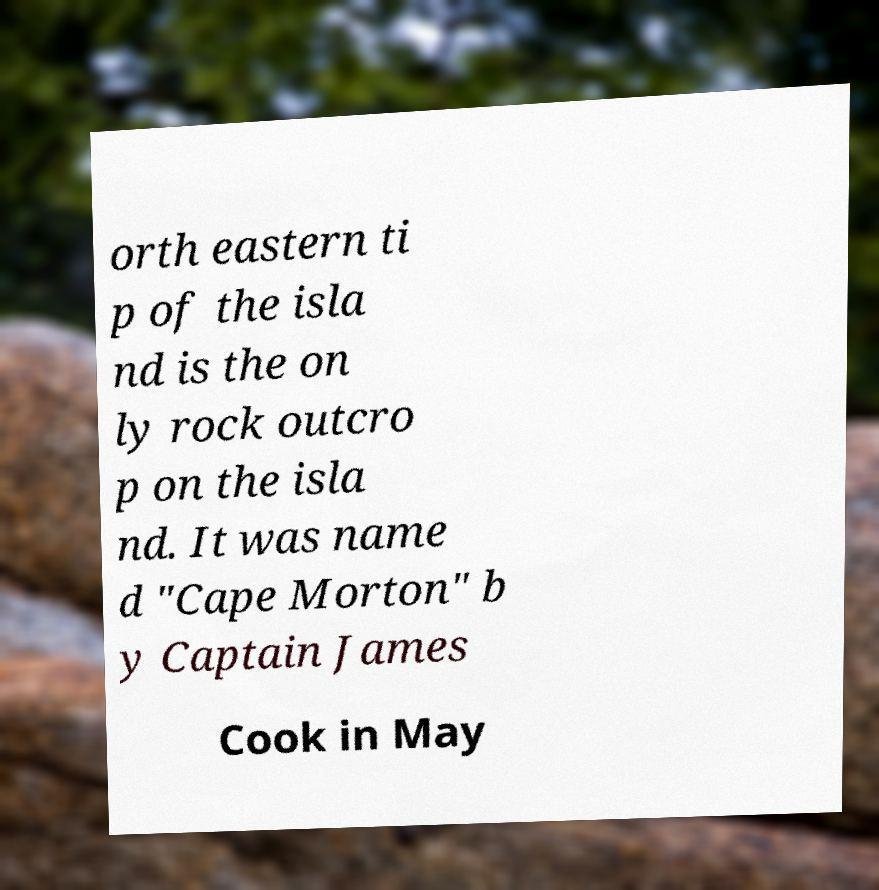Can you read and provide the text displayed in the image?This photo seems to have some interesting text. Can you extract and type it out for me? orth eastern ti p of the isla nd is the on ly rock outcro p on the isla nd. It was name d "Cape Morton" b y Captain James Cook in May 